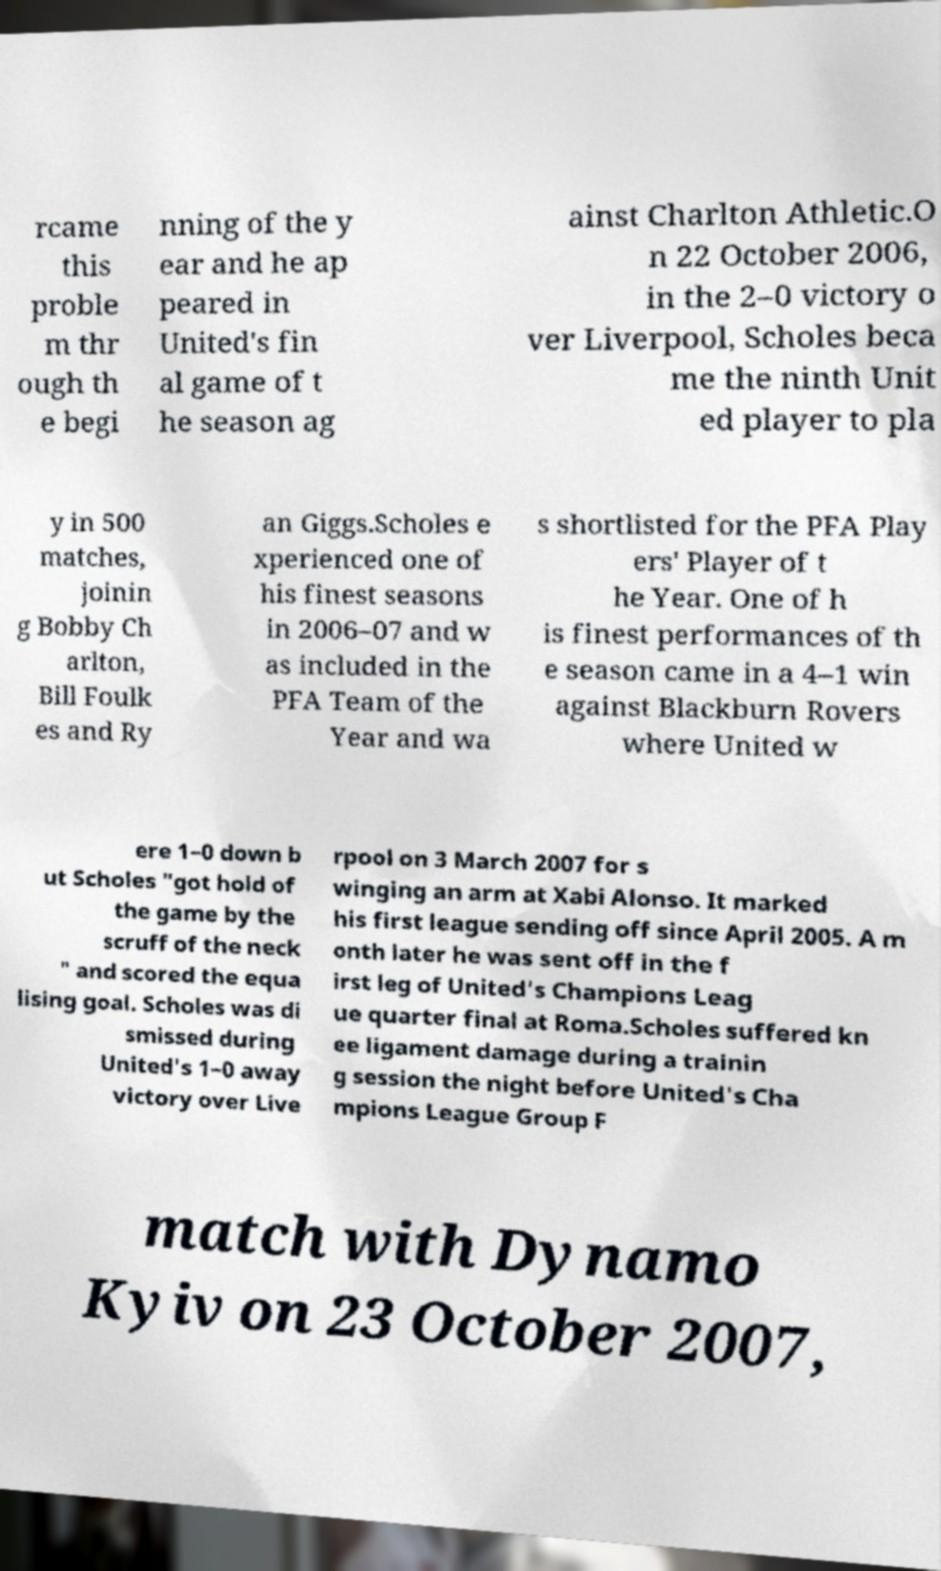Can you read and provide the text displayed in the image?This photo seems to have some interesting text. Can you extract and type it out for me? rcame this proble m thr ough th e begi nning of the y ear and he ap peared in United's fin al game of t he season ag ainst Charlton Athletic.O n 22 October 2006, in the 2–0 victory o ver Liverpool, Scholes beca me the ninth Unit ed player to pla y in 500 matches, joinin g Bobby Ch arlton, Bill Foulk es and Ry an Giggs.Scholes e xperienced one of his finest seasons in 2006–07 and w as included in the PFA Team of the Year and wa s shortlisted for the PFA Play ers' Player of t he Year. One of h is finest performances of th e season came in a 4–1 win against Blackburn Rovers where United w ere 1–0 down b ut Scholes "got hold of the game by the scruff of the neck " and scored the equa lising goal. Scholes was di smissed during United's 1–0 away victory over Live rpool on 3 March 2007 for s winging an arm at Xabi Alonso. It marked his first league sending off since April 2005. A m onth later he was sent off in the f irst leg of United's Champions Leag ue quarter final at Roma.Scholes suffered kn ee ligament damage during a trainin g session the night before United's Cha mpions League Group F match with Dynamo Kyiv on 23 October 2007, 